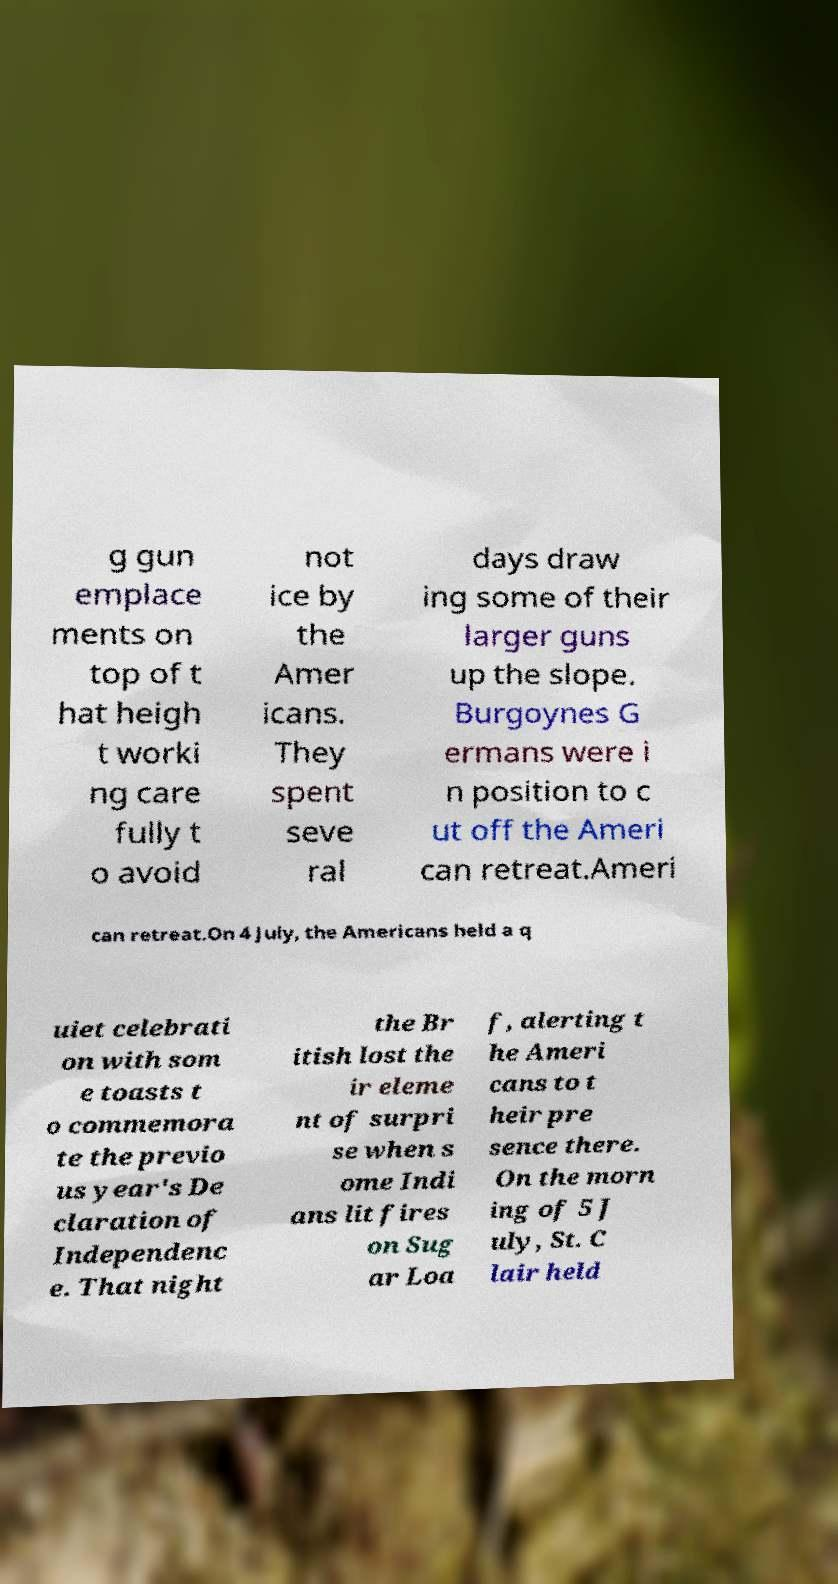I need the written content from this picture converted into text. Can you do that? g gun emplace ments on top of t hat heigh t worki ng care fully t o avoid not ice by the Amer icans. They spent seve ral days draw ing some of their larger guns up the slope. Burgoynes G ermans were i n position to c ut off the Ameri can retreat.Ameri can retreat.On 4 July, the Americans held a q uiet celebrati on with som e toasts t o commemora te the previo us year's De claration of Independenc e. That night the Br itish lost the ir eleme nt of surpri se when s ome Indi ans lit fires on Sug ar Loa f, alerting t he Ameri cans to t heir pre sence there. On the morn ing of 5 J uly, St. C lair held 